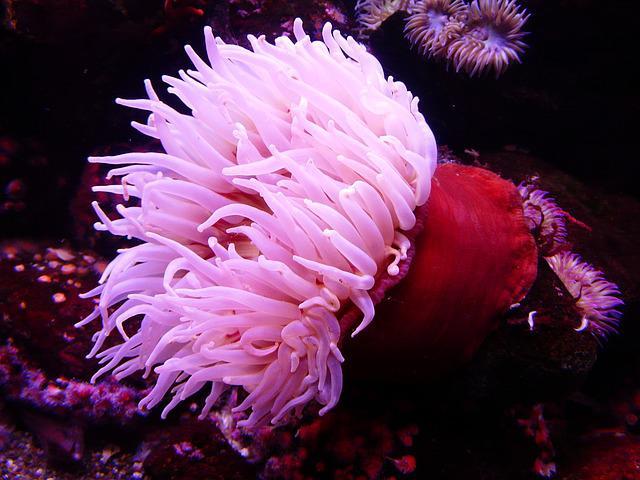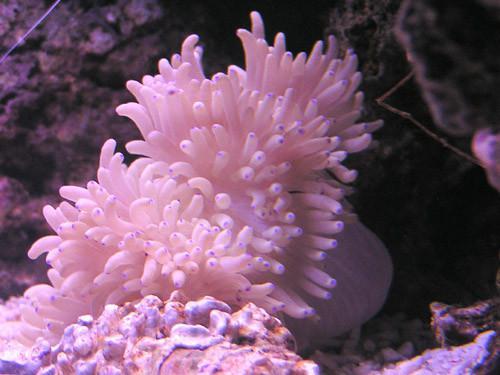The first image is the image on the left, the second image is the image on the right. For the images displayed, is the sentence "One of the sea creatures is yellowish in color and the other is pink." factually correct? Answer yes or no. No. 